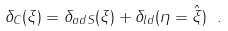Convert formula to latex. <formula><loc_0><loc_0><loc_500><loc_500>\delta _ { C } ( \xi ) = \delta _ { a d S } ( \xi ) + \delta _ { l d } ( \eta = \hat { \xi } ) \ .</formula> 